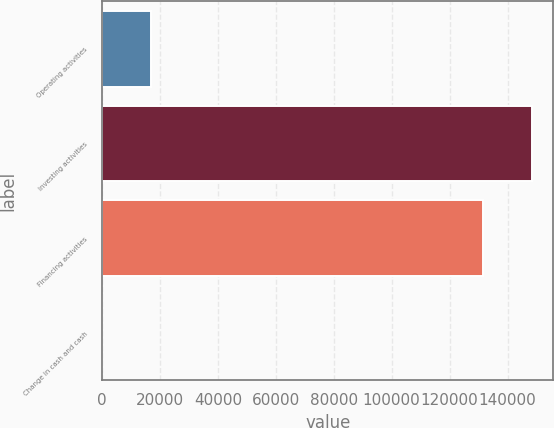Convert chart. <chart><loc_0><loc_0><loc_500><loc_500><bar_chart><fcel>Operating activities<fcel>Investing activities<fcel>Financing activities<fcel>Change in cash and cash<nl><fcel>16984<fcel>148432<fcel>131375<fcel>73<nl></chart> 